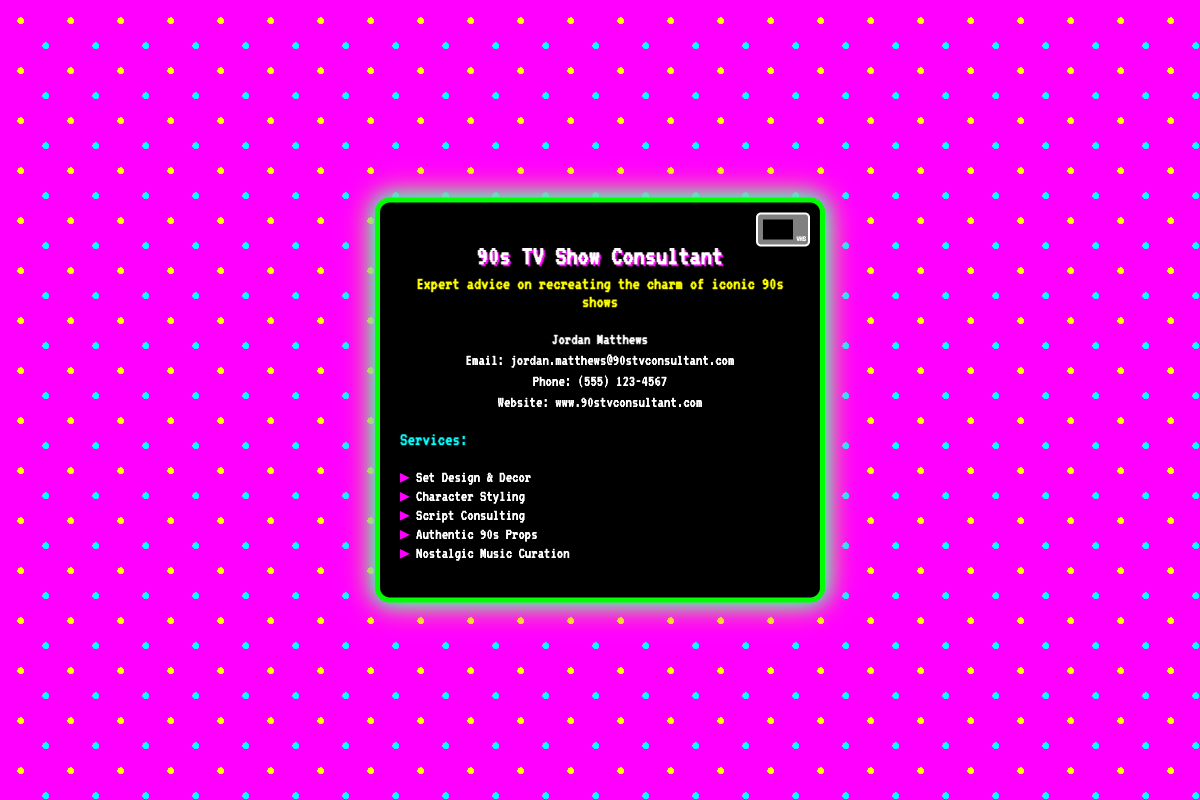What is the consultant's name? The consultant's name is prominently stated in the contact section of the document.
Answer: Jordan Matthews What is the email address provided? The email address is listed under the contact information in the document.
Answer: jordan.matthews@90stvconsultant.com What services are offered? The services are listed in a bulleted format, indicating what the consultant specializes in.
Answer: Set Design & Decor, Character Styling, Script Consulting, Authentic 90s Props, Nostalgic Music Curation What is the phone number for the consultant? The phone number can be found in the contact section of the card.
Answer: (555) 123-4567 What color is the card's background? The dominant background color is described in the styles of the card.
Answer: Black How many services are listed? The total number of services can be counted from the list provided.
Answer: Five What type of business card is this? The specific type of documentation is indicated by the title and general content layout.
Answer: Business card What theme is emphasized in this card? The theme is inferred from the title and the decorative style of the card.
Answer: 90s shows 